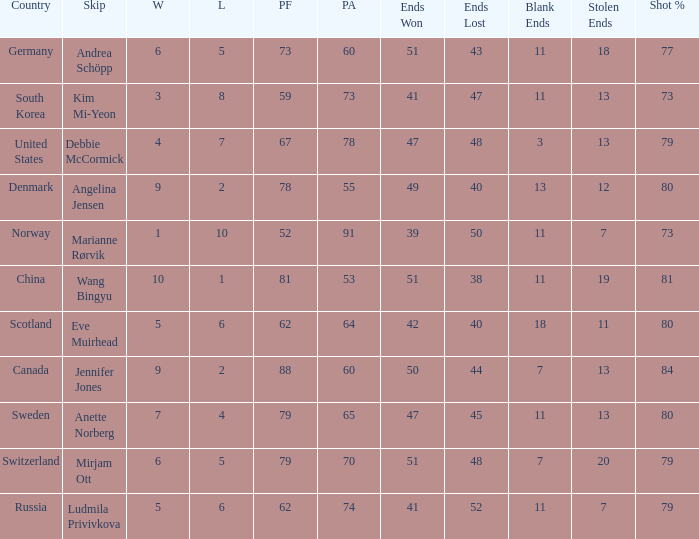Andrea Schöpp is the skip of which country? Germany. 